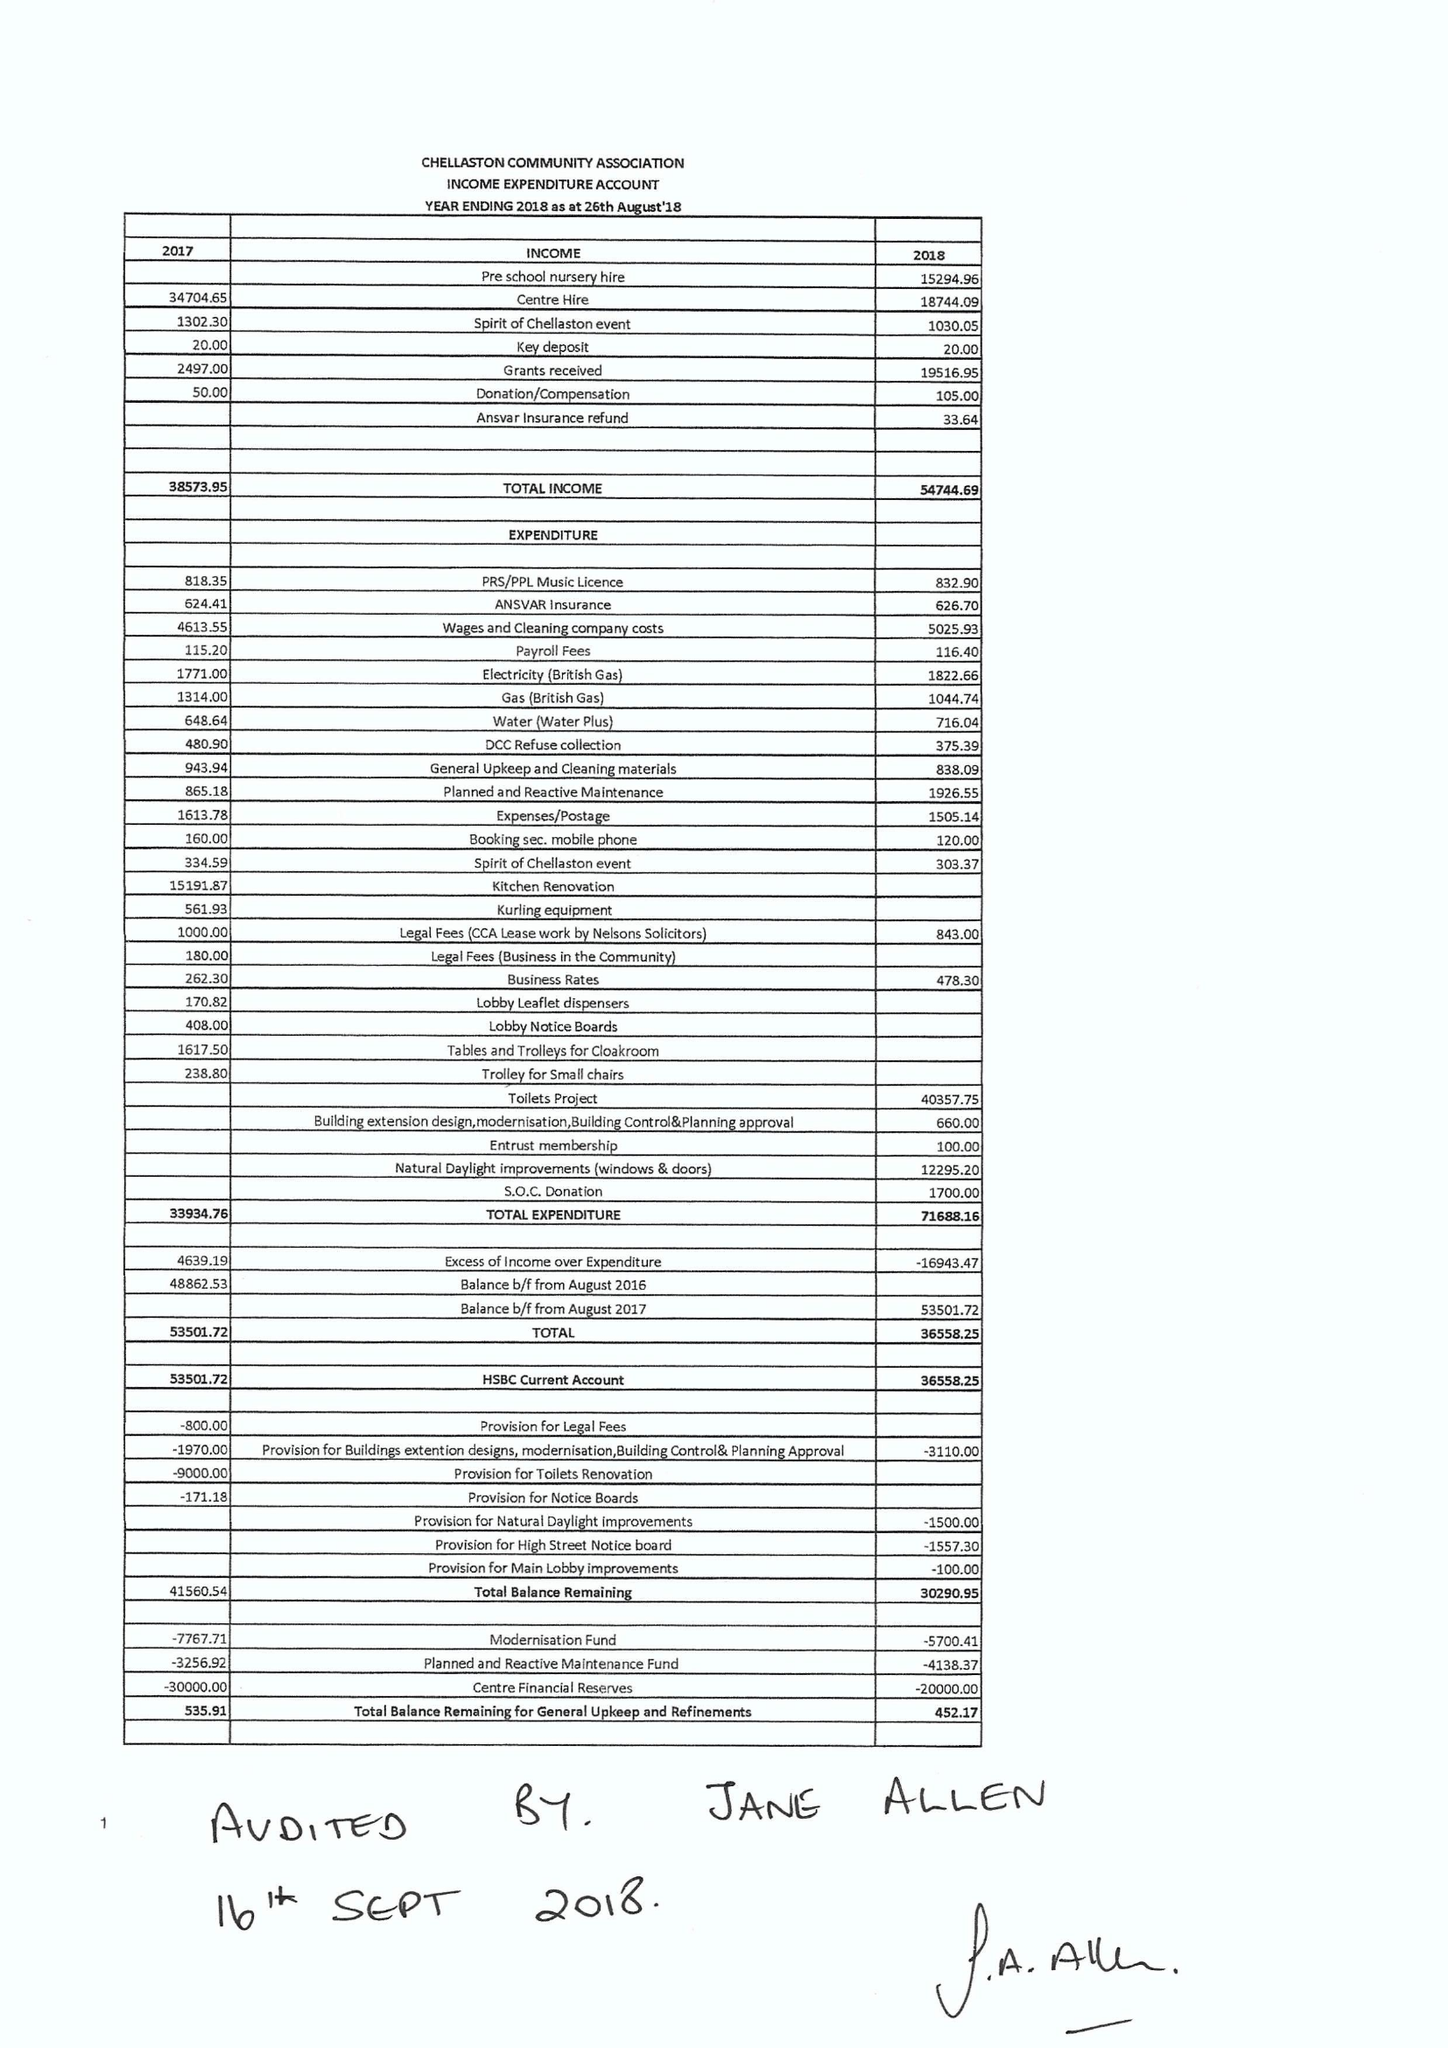What is the value for the income_annually_in_british_pounds?
Answer the question using a single word or phrase. 54744.00 